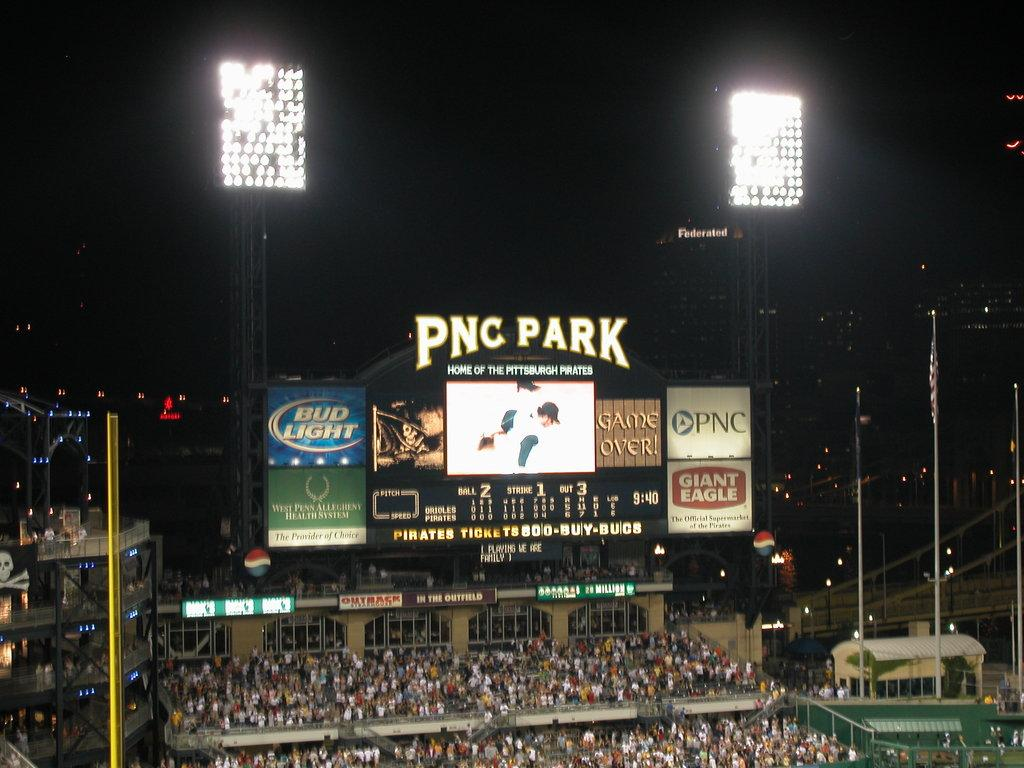<image>
Present a compact description of the photo's key features. PNC Park at night with a view of the Federated building in the background. 